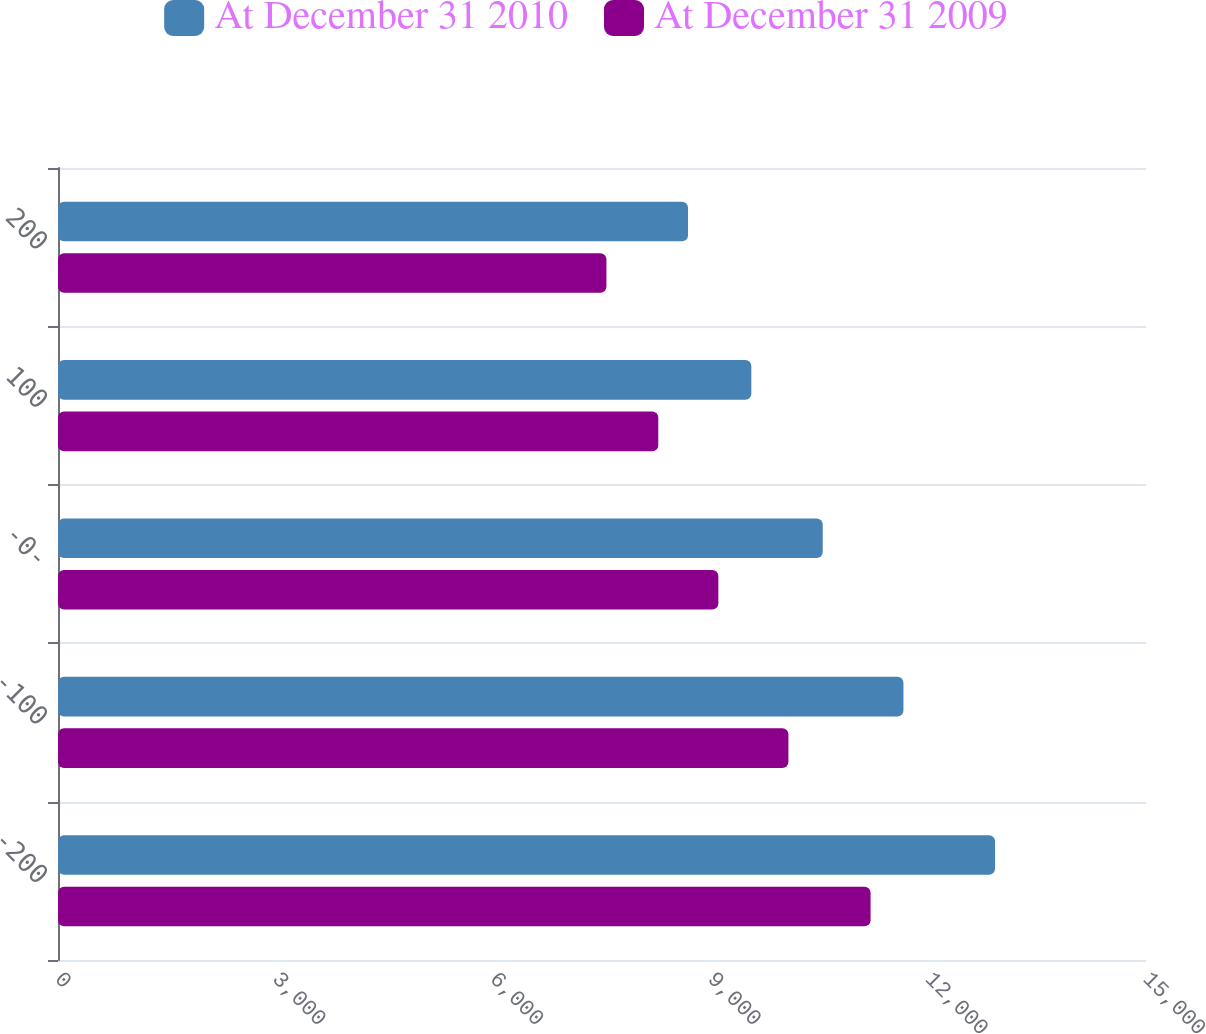Convert chart. <chart><loc_0><loc_0><loc_500><loc_500><stacked_bar_chart><ecel><fcel>-200<fcel>-100<fcel>-0-<fcel>100<fcel>200<nl><fcel>At December 31 2010<fcel>12919<fcel>11656<fcel>10543<fcel>9559<fcel>8686<nl><fcel>At December 31 2009<fcel>11203<fcel>10070<fcel>9104<fcel>8276<fcel>7561<nl></chart> 